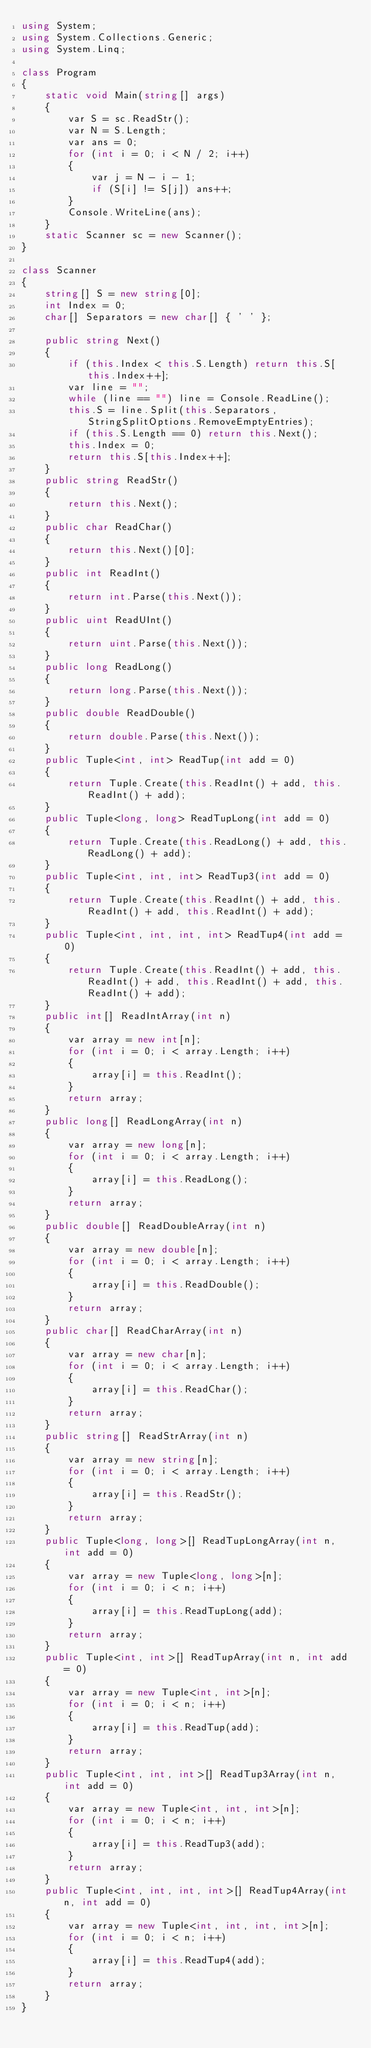Convert code to text. <code><loc_0><loc_0><loc_500><loc_500><_C#_>using System;
using System.Collections.Generic;
using System.Linq;

class Program
{
    static void Main(string[] args)
    {
        var S = sc.ReadStr();
        var N = S.Length;
        var ans = 0;
        for (int i = 0; i < N / 2; i++)
        {
            var j = N - i - 1;
            if (S[i] != S[j]) ans++;
        }
        Console.WriteLine(ans);
    }
    static Scanner sc = new Scanner();
}

class Scanner
{
    string[] S = new string[0];
    int Index = 0;
    char[] Separators = new char[] { ' ' };

    public string Next()
    {
        if (this.Index < this.S.Length) return this.S[this.Index++];
        var line = "";
        while (line == "") line = Console.ReadLine();
        this.S = line.Split(this.Separators, StringSplitOptions.RemoveEmptyEntries);
        if (this.S.Length == 0) return this.Next();
        this.Index = 0;
        return this.S[this.Index++];
    }
    public string ReadStr()
    {
        return this.Next();
    }
    public char ReadChar()
    {
        return this.Next()[0];
    }
    public int ReadInt()
    {
        return int.Parse(this.Next());
    }
    public uint ReadUInt()
    {
        return uint.Parse(this.Next());
    }
    public long ReadLong()
    {
        return long.Parse(this.Next());
    }
    public double ReadDouble()
    {
        return double.Parse(this.Next());
    }
    public Tuple<int, int> ReadTup(int add = 0)
    {
        return Tuple.Create(this.ReadInt() + add, this.ReadInt() + add);
    }
    public Tuple<long, long> ReadTupLong(int add = 0)
    {
        return Tuple.Create(this.ReadLong() + add, this.ReadLong() + add);
    }
    public Tuple<int, int, int> ReadTup3(int add = 0)
    {
        return Tuple.Create(this.ReadInt() + add, this.ReadInt() + add, this.ReadInt() + add);
    }
    public Tuple<int, int, int, int> ReadTup4(int add = 0)
    {
        return Tuple.Create(this.ReadInt() + add, this.ReadInt() + add, this.ReadInt() + add, this.ReadInt() + add);
    }
    public int[] ReadIntArray(int n)
    {
        var array = new int[n];
        for (int i = 0; i < array.Length; i++)
        {
            array[i] = this.ReadInt();
        }
        return array;
    }
    public long[] ReadLongArray(int n)
    {
        var array = new long[n];
        for (int i = 0; i < array.Length; i++)
        {
            array[i] = this.ReadLong();
        }
        return array;
    }
    public double[] ReadDoubleArray(int n)
    {
        var array = new double[n];
        for (int i = 0; i < array.Length; i++)
        {
            array[i] = this.ReadDouble();
        }
        return array;
    }
    public char[] ReadCharArray(int n)
    {
        var array = new char[n];
        for (int i = 0; i < array.Length; i++)
        {
            array[i] = this.ReadChar();
        }
        return array;
    }
    public string[] ReadStrArray(int n)
    {
        var array = new string[n];
        for (int i = 0; i < array.Length; i++)
        {
            array[i] = this.ReadStr();
        }
        return array;
    }
    public Tuple<long, long>[] ReadTupLongArray(int n, int add = 0)
    {
        var array = new Tuple<long, long>[n];
        for (int i = 0; i < n; i++)
        {
            array[i] = this.ReadTupLong(add);
        }
        return array;
    }
    public Tuple<int, int>[] ReadTupArray(int n, int add = 0)
    {
        var array = new Tuple<int, int>[n];
        for (int i = 0; i < n; i++)
        {
            array[i] = this.ReadTup(add);
        }
        return array;
    }
    public Tuple<int, int, int>[] ReadTup3Array(int n, int add = 0)
    {
        var array = new Tuple<int, int, int>[n];
        for (int i = 0; i < n; i++)
        {
            array[i] = this.ReadTup3(add);
        }
        return array;
    }
    public Tuple<int, int, int, int>[] ReadTup4Array(int n, int add = 0)
    {
        var array = new Tuple<int, int, int, int>[n];
        for (int i = 0; i < n; i++)
        {
            array[i] = this.ReadTup4(add);
        }
        return array;
    }
}
</code> 